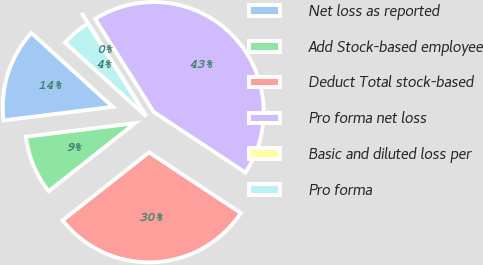Convert chart. <chart><loc_0><loc_0><loc_500><loc_500><pie_chart><fcel>Net loss as reported<fcel>Add Stock-based employee<fcel>Deduct Total stock-based<fcel>Pro forma net loss<fcel>Basic and diluted loss per<fcel>Pro forma<nl><fcel>13.7%<fcel>8.65%<fcel>30.1%<fcel>43.23%<fcel>0.0%<fcel>4.32%<nl></chart> 